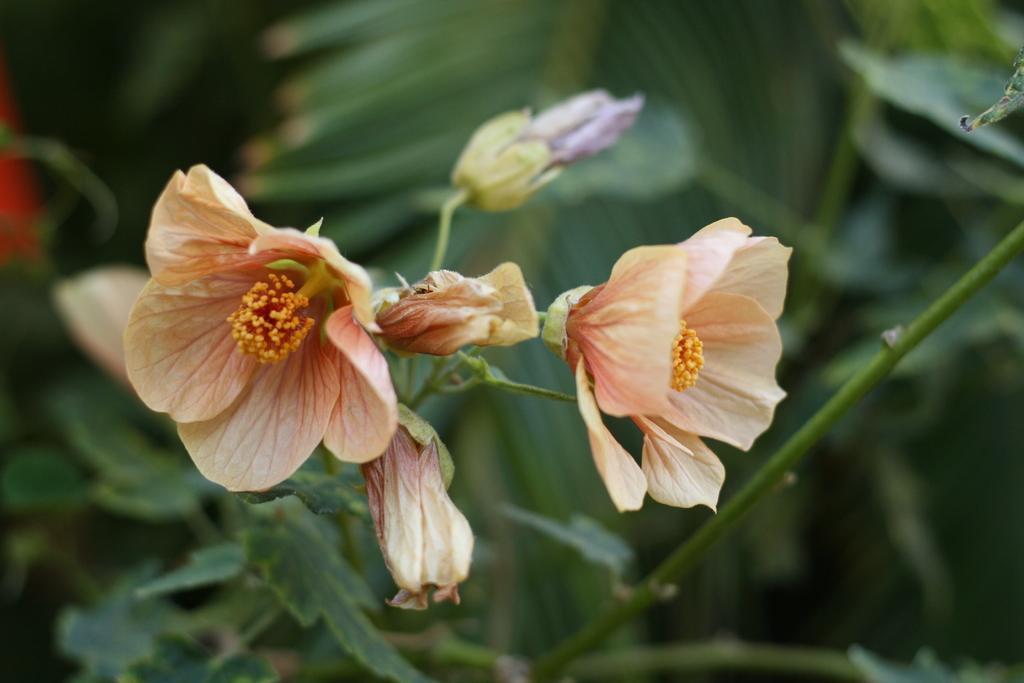Can you describe this image briefly? In this given picture, We can see flowers and a stem after that, We can see a few trees next few leaves. 